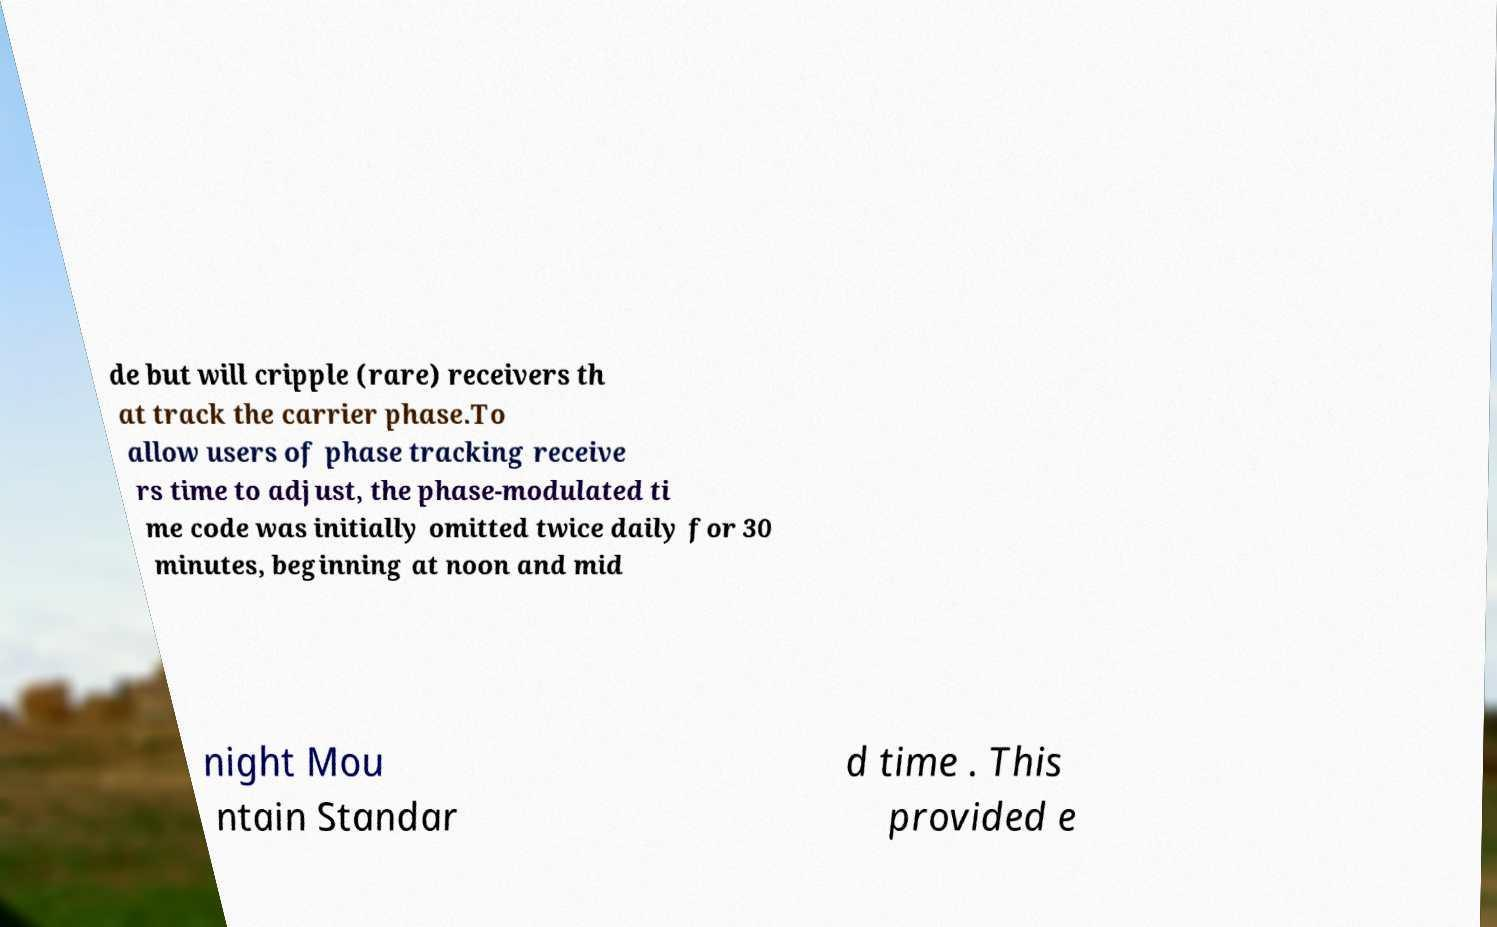Please read and relay the text visible in this image. What does it say? de but will cripple (rare) receivers th at track the carrier phase.To allow users of phase tracking receive rs time to adjust, the phase-modulated ti me code was initially omitted twice daily for 30 minutes, beginning at noon and mid night Mou ntain Standar d time . This provided e 